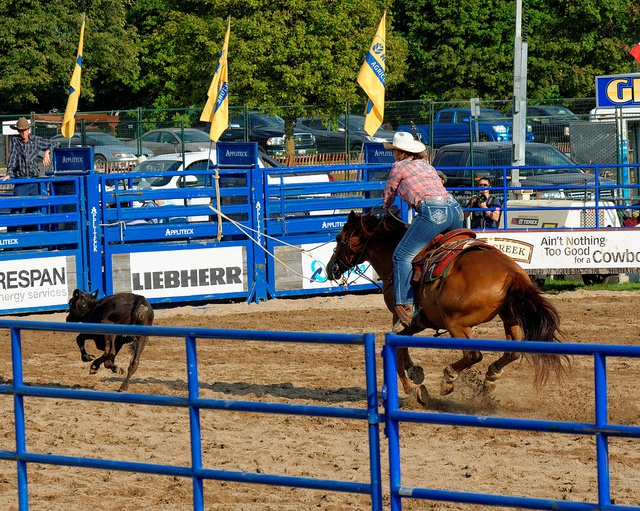Describe the objects in this image and their specific colors. I can see horse in darkgreen, black, maroon, and brown tones, truck in darkgreen, blue, white, and navy tones, people in darkgreen, blue, lightpink, navy, and darkgray tones, car in darkgreen, black, navy, gray, and blue tones, and cow in darkgreen, black, maroon, and gray tones in this image. 